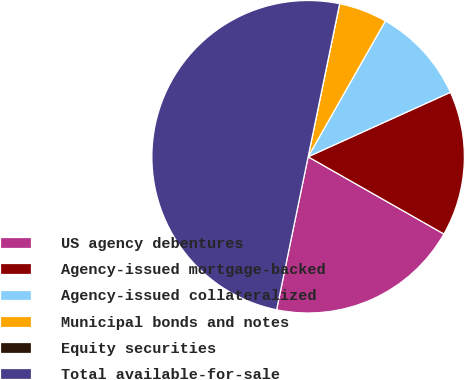Convert chart to OTSL. <chart><loc_0><loc_0><loc_500><loc_500><pie_chart><fcel>US agency debentures<fcel>Agency-issued mortgage-backed<fcel>Agency-issued collateralized<fcel>Municipal bonds and notes<fcel>Equity securities<fcel>Total available-for-sale<nl><fcel>20.0%<fcel>15.0%<fcel>10.0%<fcel>5.0%<fcel>0.0%<fcel>50.0%<nl></chart> 